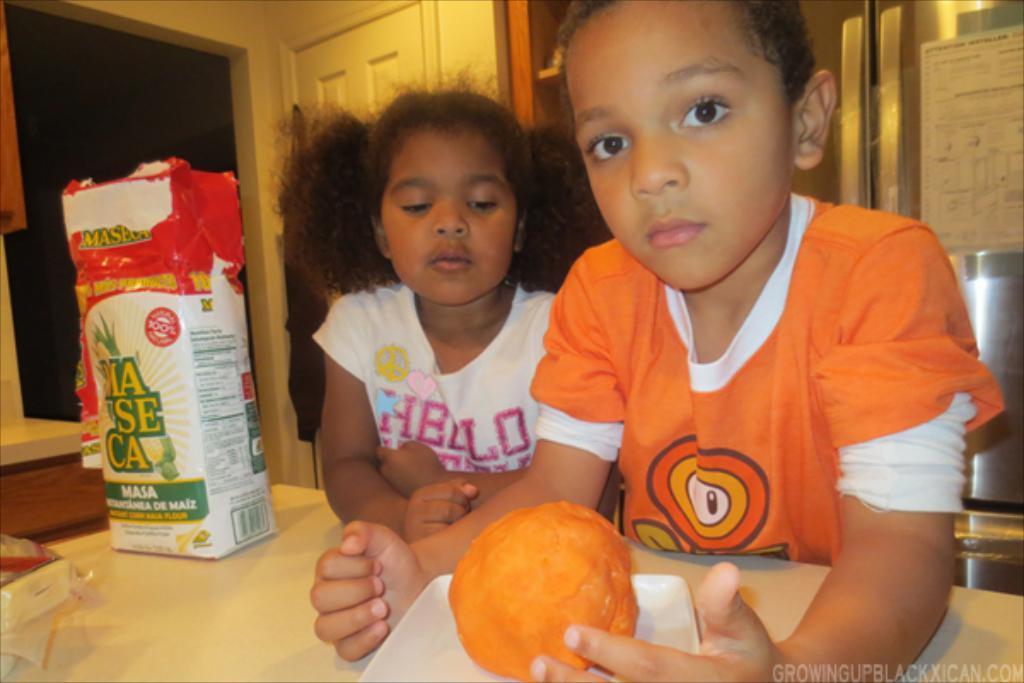Describe this image in one or two sentences. 2 children are present. The person at the right is wearing an orange t shirt. There is a table in the front on which there is a white plate which has a food item and a box. There is a door at the back. 